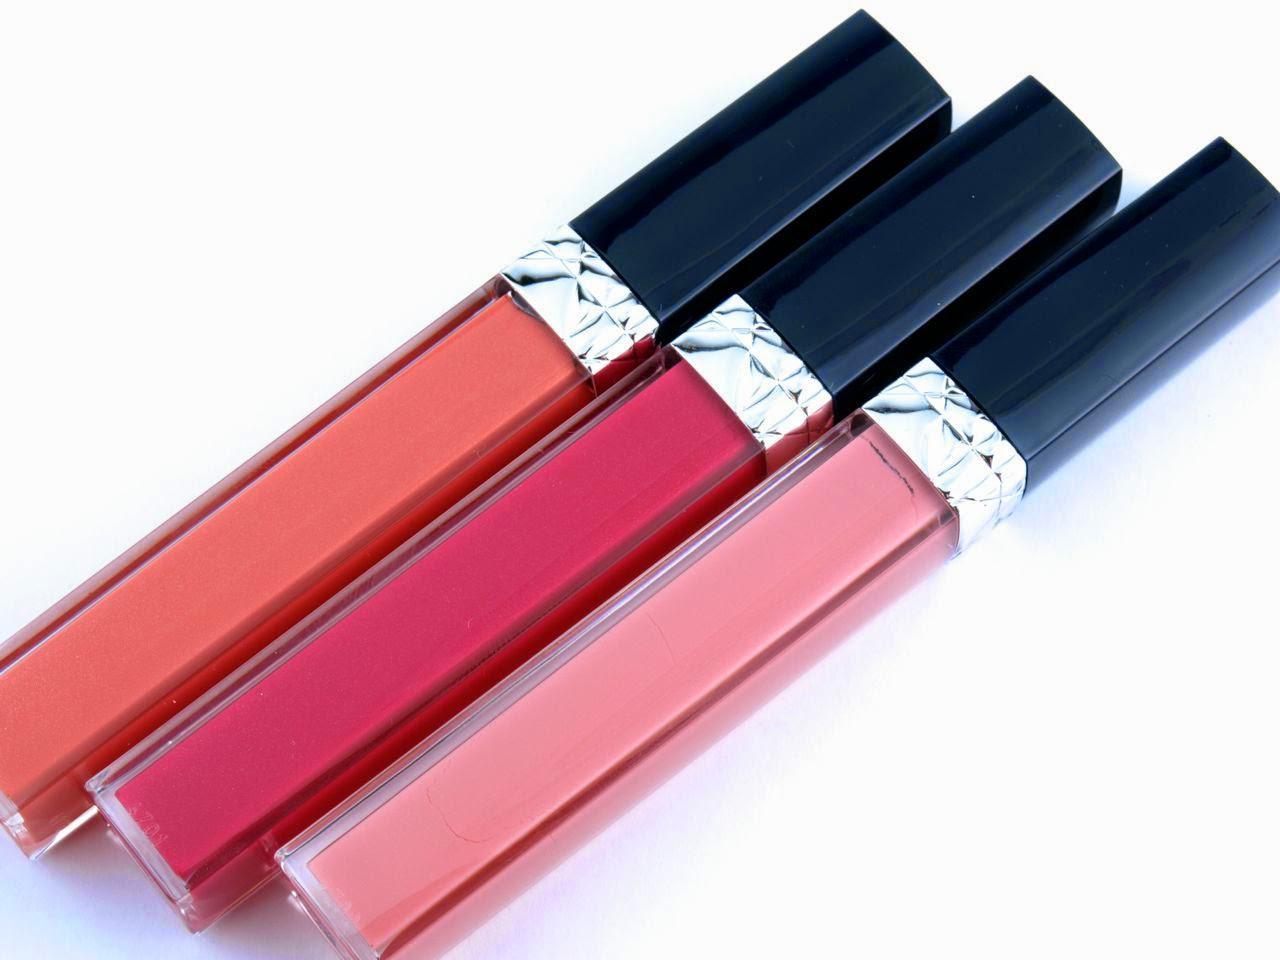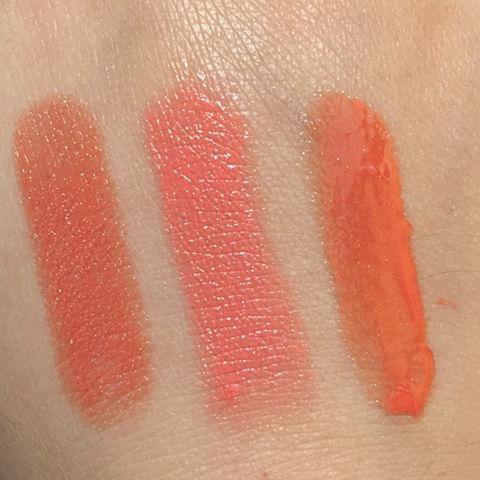The first image is the image on the left, the second image is the image on the right. Assess this claim about the two images: "There are three lipsticks in the image on the left". Correct or not? Answer yes or no. Yes. The first image is the image on the left, the second image is the image on the right. Analyze the images presented: Is the assertion "A pair of lips is shown in each image." valid? Answer yes or no. No. The first image is the image on the left, the second image is the image on the right. Evaluate the accuracy of this statement regarding the images: "There are at least three containers of lipstick.". Is it true? Answer yes or no. Yes. 